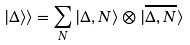<formula> <loc_0><loc_0><loc_500><loc_500>| \Delta \rangle \rangle = \sum _ { N } | \Delta , N \rangle \otimes | \overline { \Delta , N } \rangle</formula> 